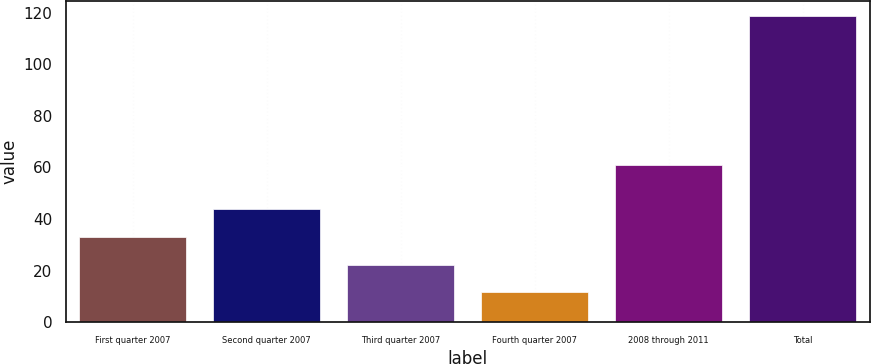Convert chart. <chart><loc_0><loc_0><loc_500><loc_500><bar_chart><fcel>First quarter 2007<fcel>Second quarter 2007<fcel>Third quarter 2007<fcel>Fourth quarter 2007<fcel>2008 through 2011<fcel>Total<nl><fcel>33.02<fcel>43.73<fcel>22.31<fcel>11.6<fcel>60.9<fcel>118.7<nl></chart> 